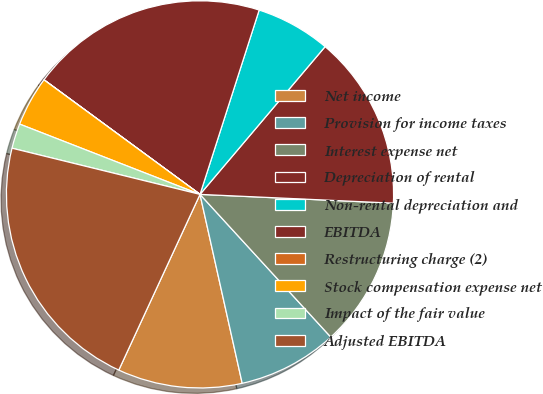Convert chart to OTSL. <chart><loc_0><loc_0><loc_500><loc_500><pie_chart><fcel>Net income<fcel>Provision for income taxes<fcel>Interest expense net<fcel>Depreciation of rental<fcel>Non-rental depreciation and<fcel>EBITDA<fcel>Restructuring charge (2)<fcel>Stock compensation expense net<fcel>Impact of the fair value<fcel>Adjusted EBITDA<nl><fcel>10.39%<fcel>8.31%<fcel>12.47%<fcel>14.54%<fcel>6.24%<fcel>19.86%<fcel>0.01%<fcel>4.16%<fcel>2.08%<fcel>21.94%<nl></chart> 